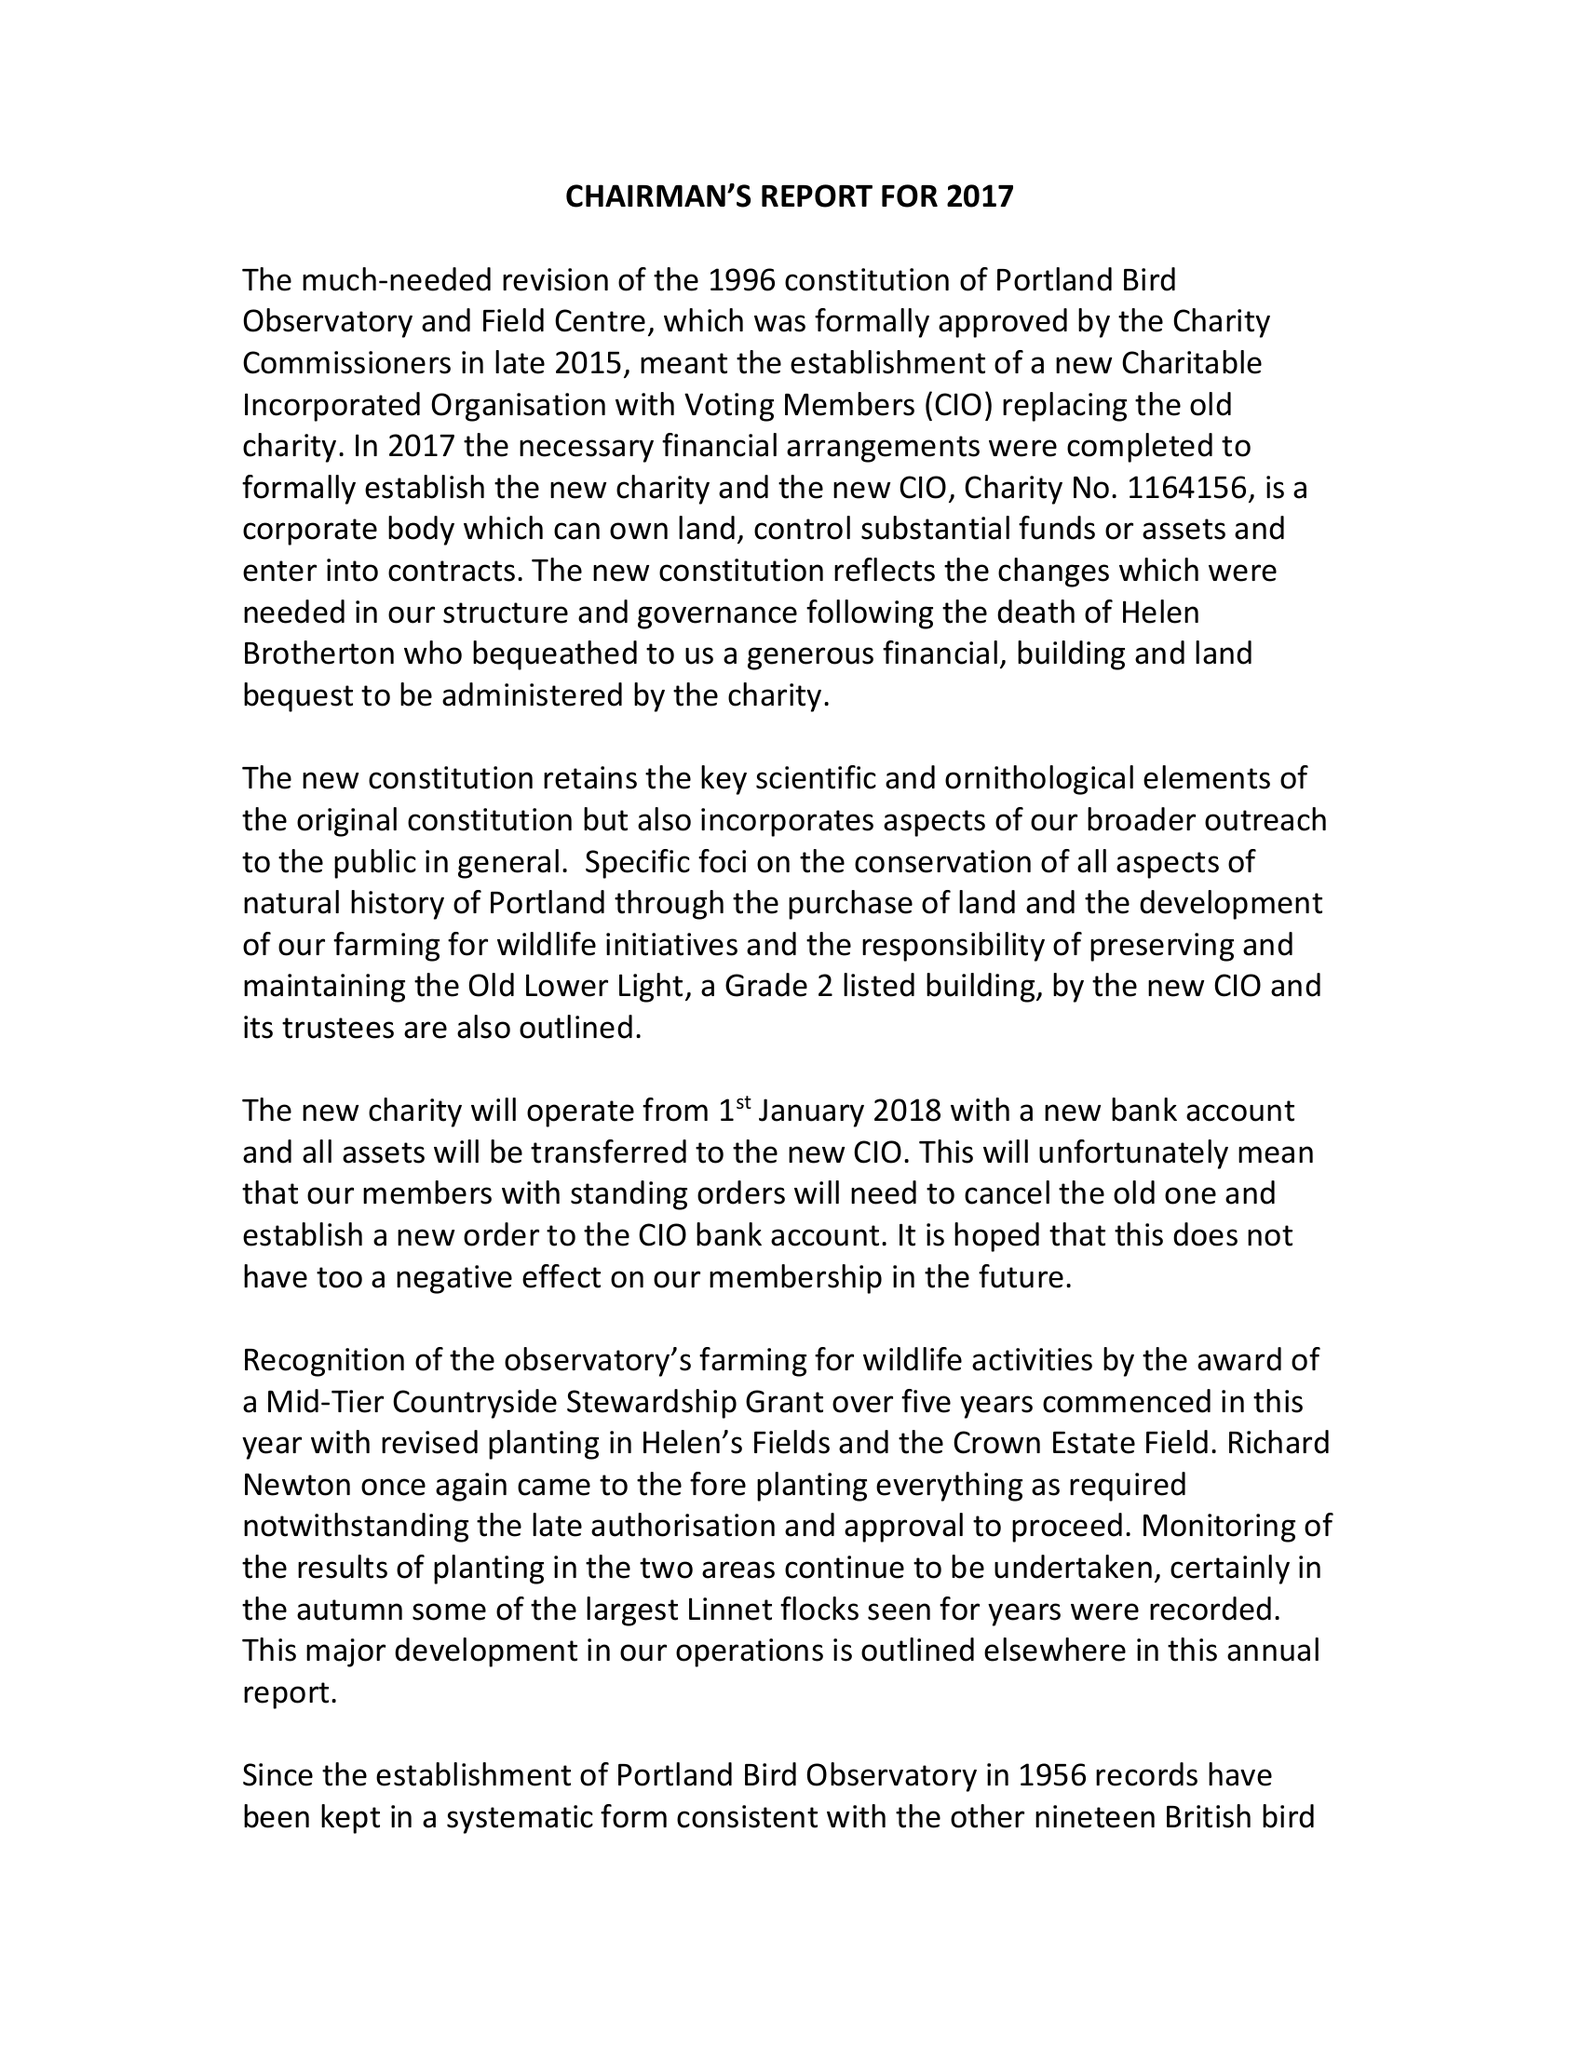What is the value for the report_date?
Answer the question using a single word or phrase. 2017-12-31 